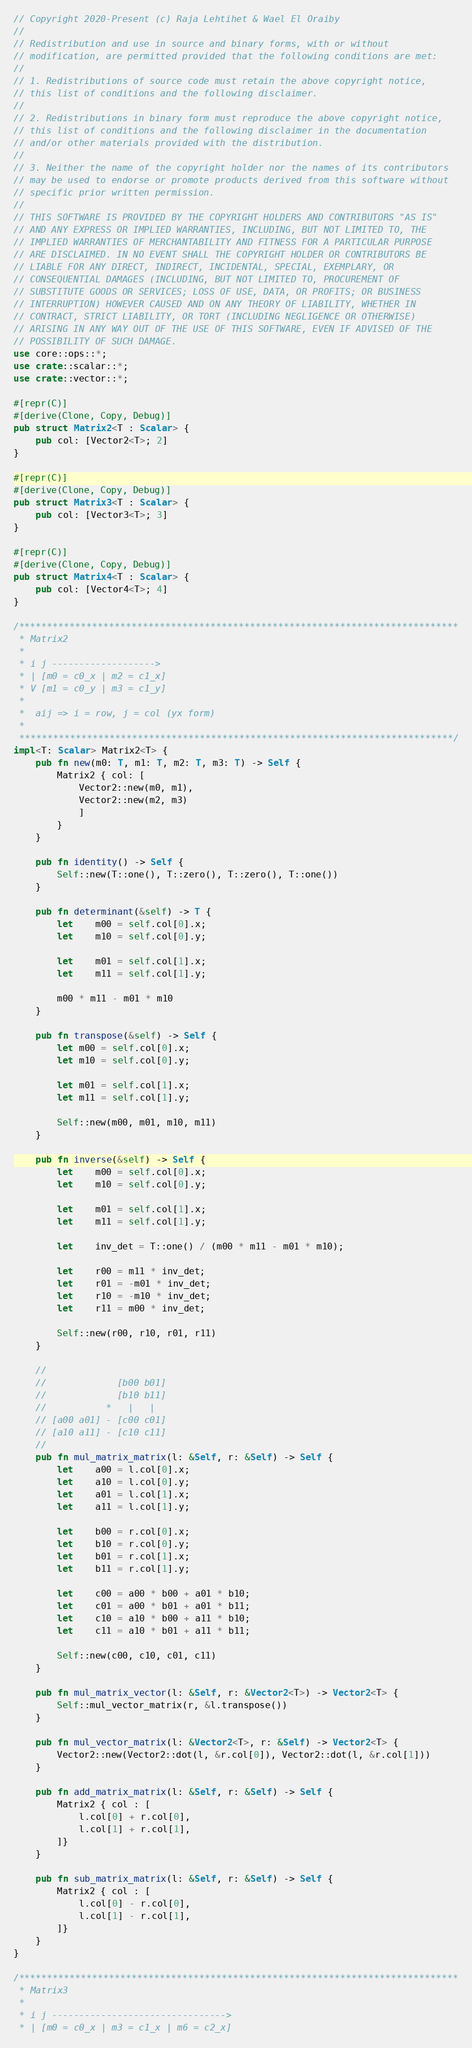Convert code to text. <code><loc_0><loc_0><loc_500><loc_500><_Rust_>// Copyright 2020-Present (c) Raja Lehtihet & Wael El Oraiby
//
// Redistribution and use in source and binary forms, with or without
// modification, are permitted provided that the following conditions are met:
//
// 1. Redistributions of source code must retain the above copyright notice,
// this list of conditions and the following disclaimer.
//
// 2. Redistributions in binary form must reproduce the above copyright notice,
// this list of conditions and the following disclaimer in the documentation
// and/or other materials provided with the distribution.
//
// 3. Neither the name of the copyright holder nor the names of its contributors
// may be used to endorse or promote products derived from this software without
// specific prior written permission.
//
// THIS SOFTWARE IS PROVIDED BY THE COPYRIGHT HOLDERS AND CONTRIBUTORS "AS IS"
// AND ANY EXPRESS OR IMPLIED WARRANTIES, INCLUDING, BUT NOT LIMITED TO, THE
// IMPLIED WARRANTIES OF MERCHANTABILITY AND FITNESS FOR A PARTICULAR PURPOSE
// ARE DISCLAIMED. IN NO EVENT SHALL THE COPYRIGHT HOLDER OR CONTRIBUTORS BE
// LIABLE FOR ANY DIRECT, INDIRECT, INCIDENTAL, SPECIAL, EXEMPLARY, OR
// CONSEQUENTIAL DAMAGES (INCLUDING, BUT NOT LIMITED TO, PROCUREMENT OF
// SUBSTITUTE GOODS OR SERVICES; LOSS OF USE, DATA, OR PROFITS; OR BUSINESS
// INTERRUPTION) HOWEVER CAUSED AND ON ANY THEORY OF LIABILITY, WHETHER IN
// CONTRACT, STRICT LIABILITY, OR TORT (INCLUDING NEGLIGENCE OR OTHERWISE)
// ARISING IN ANY WAY OUT OF THE USE OF THIS SOFTWARE, EVEN IF ADVISED OF THE
// POSSIBILITY OF SUCH DAMAGE.
use core::ops::*;
use crate::scalar::*;
use crate::vector::*;

#[repr(C)]
#[derive(Clone, Copy, Debug)]
pub struct Matrix2<T : Scalar> {
    pub col: [Vector2<T>; 2]
}

#[repr(C)]
#[derive(Clone, Copy, Debug)]
pub struct Matrix3<T : Scalar> {
    pub col: [Vector3<T>; 3]
}

#[repr(C)]
#[derive(Clone, Copy, Debug)]
pub struct Matrix4<T : Scalar> {
    pub col: [Vector4<T>; 4]
}

/******************************************************************************
 * Matrix2
 *
 * i j ------------------->
 * | [m0 = c0_x | m2 = c1_x]
 * V [m1 = c0_y | m3 = c1_y]
 *
 *  aij => i = row, j = col (yx form)
 *
 *****************************************************************************/
impl<T: Scalar> Matrix2<T> {
    pub fn new(m0: T, m1: T, m2: T, m3: T) -> Self {
        Matrix2 { col: [
            Vector2::new(m0, m1),
            Vector2::new(m2, m3)
            ]
        }
    }

    pub fn identity() -> Self {
        Self::new(T::one(), T::zero(), T::zero(), T::one())
    }

    pub fn determinant(&self) -> T {
        let	m00 = self.col[0].x;
        let	m10 = self.col[0].y;

        let	m01 = self.col[1].x;
        let	m11 = self.col[1].y;

        m00 * m11 - m01 * m10
    }

    pub fn transpose(&self) -> Self {
        let m00 = self.col[0].x;
        let m10 = self.col[0].y;

        let m01 = self.col[1].x;
        let m11 = self.col[1].y;

        Self::new(m00, m01, m10, m11)
    }

    pub fn inverse(&self) -> Self {
        let	m00 = self.col[0].x;
        let	m10 = self.col[0].y;

        let	m01 = self.col[1].x;
        let	m11 = self.col[1].y;

        let	inv_det = T::one() / (m00 * m11 - m01 * m10);

        let	r00 = m11 * inv_det;
        let	r01 = -m01 * inv_det;
        let	r10 = -m10 * inv_det;
        let	r11 = m00 * inv_det;

        Self::new(r00, r10, r01, r11)
    }

    //
    //             [b00 b01]
    //             [b10 b11]
    //           *   |   |
    // [a00 a01] - [c00 c01]
    // [a10 a11] - [c10 c11]
    //
    pub fn mul_matrix_matrix(l: &Self, r: &Self) -> Self {
        let	a00 = l.col[0].x;
        let	a10 = l.col[0].y;
        let	a01 = l.col[1].x;
        let	a11 = l.col[1].y;

        let	b00 = r.col[0].x;
        let	b10 = r.col[0].y;
        let	b01 = r.col[1].x;
        let	b11 = r.col[1].y;

        let	c00 = a00 * b00 + a01 * b10;
        let	c01 = a00 * b01 + a01 * b11;
        let	c10 = a10 * b00 + a11 * b10;
        let	c11 = a10 * b01 + a11 * b11;

        Self::new(c00, c10, c01, c11)
    }

    pub fn mul_matrix_vector(l: &Self, r: &Vector2<T>) -> Vector2<T> {
        Self::mul_vector_matrix(r, &l.transpose())
    }

    pub fn mul_vector_matrix(l: &Vector2<T>, r: &Self) -> Vector2<T> {
        Vector2::new(Vector2::dot(l, &r.col[0]), Vector2::dot(l, &r.col[1]))
    }

    pub fn add_matrix_matrix(l: &Self, r: &Self) -> Self {
        Matrix2 { col : [
            l.col[0] + r.col[0],
            l.col[1] + r.col[1],
        ]}
    }

    pub fn sub_matrix_matrix(l: &Self, r: &Self) -> Self {
        Matrix2 { col : [
            l.col[0] - r.col[0],
            l.col[1] - r.col[1],
        ]}
    }
}

/******************************************************************************
 * Matrix3
 *
 * i j -------------------------------->
 * | [m0 = c0_x | m3 = c1_x | m6 = c2_x]</code> 